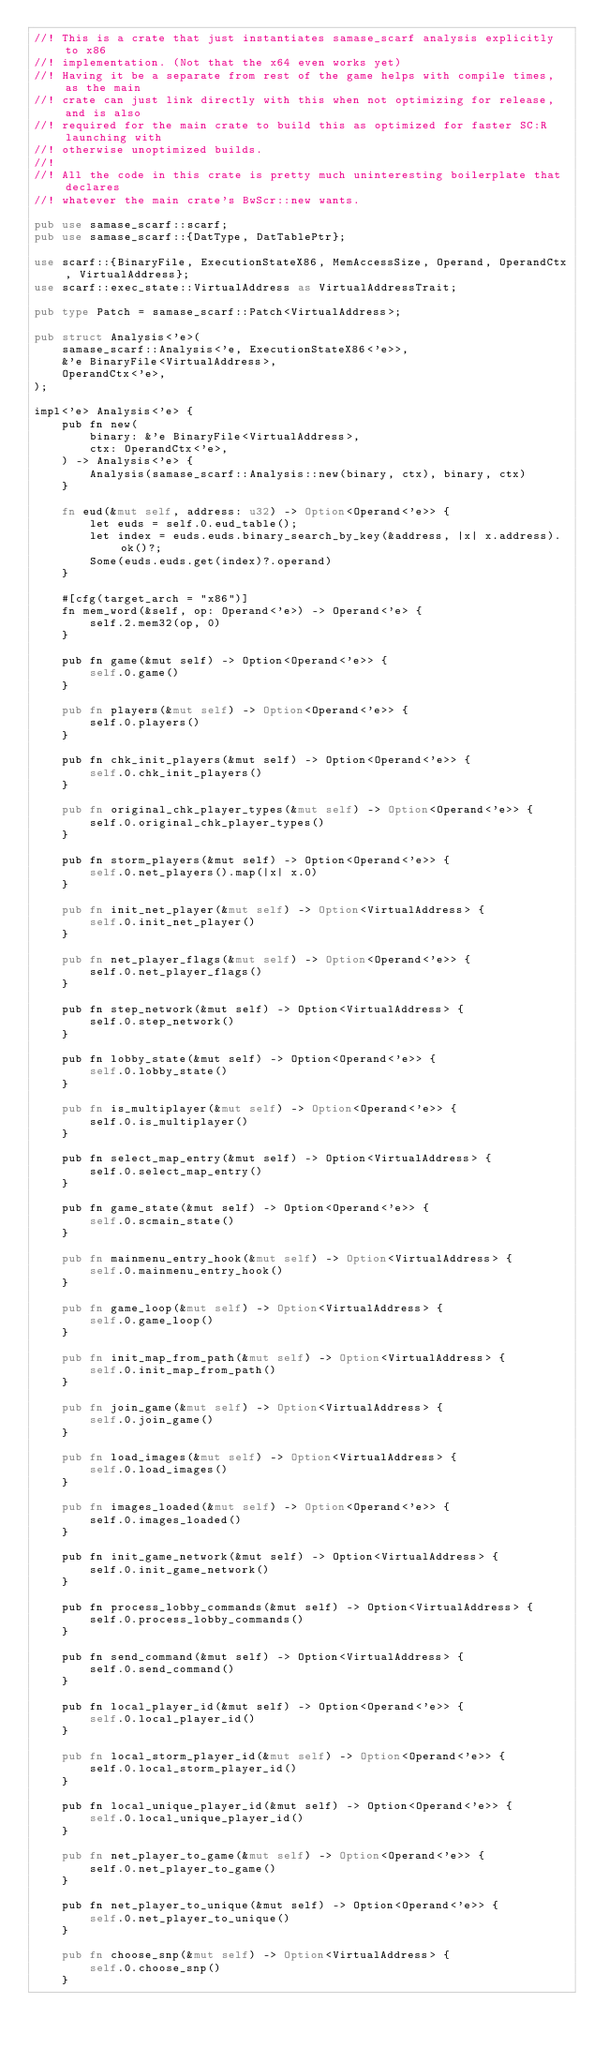Convert code to text. <code><loc_0><loc_0><loc_500><loc_500><_Rust_>//! This is a crate that just instantiates samase_scarf analysis explicitly to x86
//! implementation. (Not that the x64 even works yet)
//! Having it be a separate from rest of the game helps with compile times, as the main
//! crate can just link directly with this when not optimizing for release, and is also
//! required for the main crate to build this as optimized for faster SC:R launching with
//! otherwise unoptimized builds.
//!
//! All the code in this crate is pretty much uninteresting boilerplate that declares
//! whatever the main crate's BwScr::new wants.

pub use samase_scarf::scarf;
pub use samase_scarf::{DatType, DatTablePtr};

use scarf::{BinaryFile, ExecutionStateX86, MemAccessSize, Operand, OperandCtx, VirtualAddress};
use scarf::exec_state::VirtualAddress as VirtualAddressTrait;

pub type Patch = samase_scarf::Patch<VirtualAddress>;

pub struct Analysis<'e>(
    samase_scarf::Analysis<'e, ExecutionStateX86<'e>>,
    &'e BinaryFile<VirtualAddress>,
    OperandCtx<'e>,
);

impl<'e> Analysis<'e> {
    pub fn new(
        binary: &'e BinaryFile<VirtualAddress>,
        ctx: OperandCtx<'e>,
    ) -> Analysis<'e> {
        Analysis(samase_scarf::Analysis::new(binary, ctx), binary, ctx)
    }

    fn eud(&mut self, address: u32) -> Option<Operand<'e>> {
        let euds = self.0.eud_table();
        let index = euds.euds.binary_search_by_key(&address, |x| x.address).ok()?;
        Some(euds.euds.get(index)?.operand)
    }

    #[cfg(target_arch = "x86")]
    fn mem_word(&self, op: Operand<'e>) -> Operand<'e> {
        self.2.mem32(op, 0)
    }

    pub fn game(&mut self) -> Option<Operand<'e>> {
        self.0.game()
    }

    pub fn players(&mut self) -> Option<Operand<'e>> {
        self.0.players()
    }

    pub fn chk_init_players(&mut self) -> Option<Operand<'e>> {
        self.0.chk_init_players()
    }

    pub fn original_chk_player_types(&mut self) -> Option<Operand<'e>> {
        self.0.original_chk_player_types()
    }

    pub fn storm_players(&mut self) -> Option<Operand<'e>> {
        self.0.net_players().map(|x| x.0)
    }

    pub fn init_net_player(&mut self) -> Option<VirtualAddress> {
        self.0.init_net_player()
    }

    pub fn net_player_flags(&mut self) -> Option<Operand<'e>> {
        self.0.net_player_flags()
    }

    pub fn step_network(&mut self) -> Option<VirtualAddress> {
        self.0.step_network()
    }

    pub fn lobby_state(&mut self) -> Option<Operand<'e>> {
        self.0.lobby_state()
    }

    pub fn is_multiplayer(&mut self) -> Option<Operand<'e>> {
        self.0.is_multiplayer()
    }

    pub fn select_map_entry(&mut self) -> Option<VirtualAddress> {
        self.0.select_map_entry()
    }

    pub fn game_state(&mut self) -> Option<Operand<'e>> {
        self.0.scmain_state()
    }

    pub fn mainmenu_entry_hook(&mut self) -> Option<VirtualAddress> {
        self.0.mainmenu_entry_hook()
    }

    pub fn game_loop(&mut self) -> Option<VirtualAddress> {
        self.0.game_loop()
    }

    pub fn init_map_from_path(&mut self) -> Option<VirtualAddress> {
        self.0.init_map_from_path()
    }

    pub fn join_game(&mut self) -> Option<VirtualAddress> {
        self.0.join_game()
    }

    pub fn load_images(&mut self) -> Option<VirtualAddress> {
        self.0.load_images()
    }

    pub fn images_loaded(&mut self) -> Option<Operand<'e>> {
        self.0.images_loaded()
    }

    pub fn init_game_network(&mut self) -> Option<VirtualAddress> {
        self.0.init_game_network()
    }

    pub fn process_lobby_commands(&mut self) -> Option<VirtualAddress> {
        self.0.process_lobby_commands()
    }

    pub fn send_command(&mut self) -> Option<VirtualAddress> {
        self.0.send_command()
    }

    pub fn local_player_id(&mut self) -> Option<Operand<'e>> {
        self.0.local_player_id()
    }

    pub fn local_storm_player_id(&mut self) -> Option<Operand<'e>> {
        self.0.local_storm_player_id()
    }

    pub fn local_unique_player_id(&mut self) -> Option<Operand<'e>> {
        self.0.local_unique_player_id()
    }

    pub fn net_player_to_game(&mut self) -> Option<Operand<'e>> {
        self.0.net_player_to_game()
    }

    pub fn net_player_to_unique(&mut self) -> Option<Operand<'e>> {
        self.0.net_player_to_unique()
    }

    pub fn choose_snp(&mut self) -> Option<VirtualAddress> {
        self.0.choose_snp()
    }
</code> 